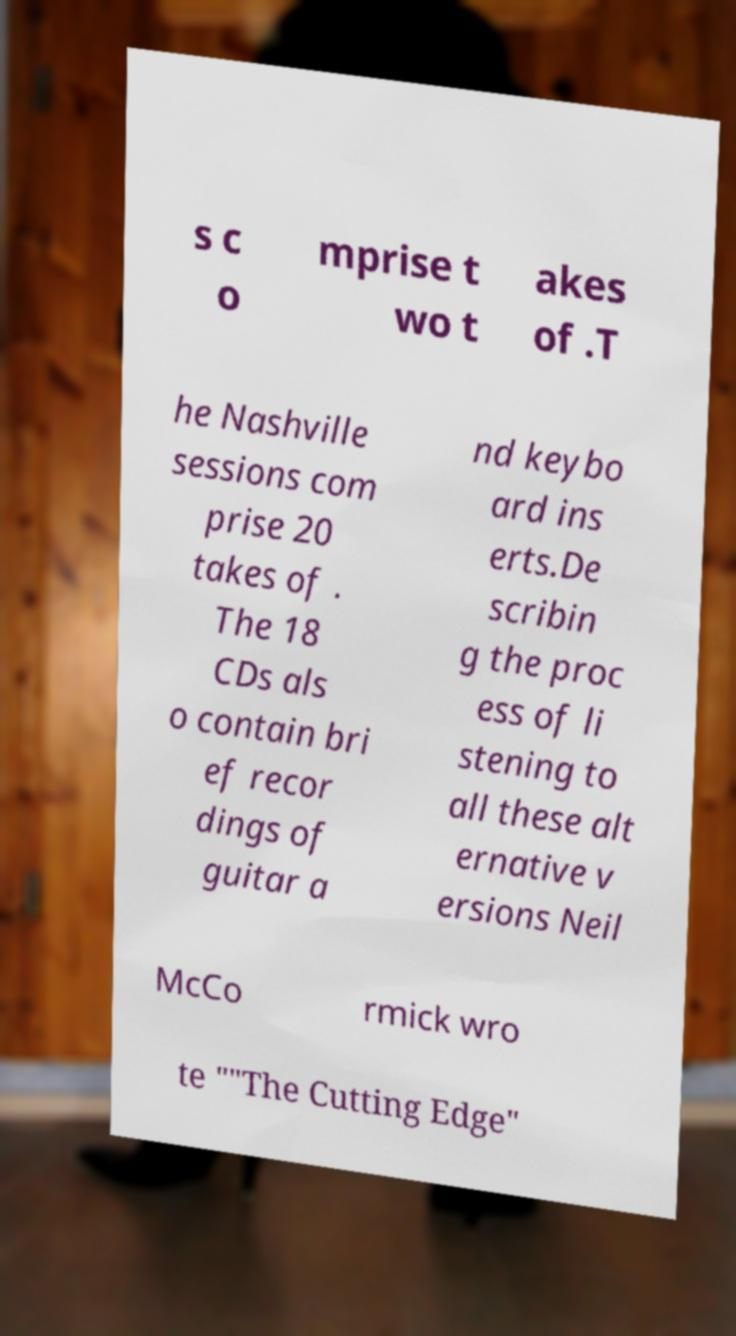Can you read and provide the text displayed in the image?This photo seems to have some interesting text. Can you extract and type it out for me? s c o mprise t wo t akes of .T he Nashville sessions com prise 20 takes of . The 18 CDs als o contain bri ef recor dings of guitar a nd keybo ard ins erts.De scribin g the proc ess of li stening to all these alt ernative v ersions Neil McCo rmick wro te ""The Cutting Edge" 